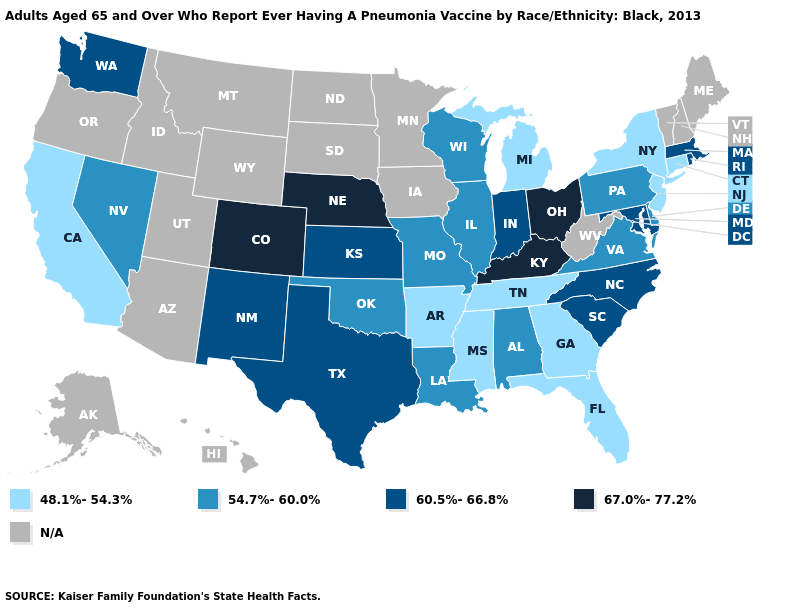Does Wisconsin have the lowest value in the USA?
Write a very short answer. No. Does Kentucky have the highest value in the USA?
Concise answer only. Yes. What is the value of California?
Give a very brief answer. 48.1%-54.3%. What is the highest value in states that border Massachusetts?
Short answer required. 60.5%-66.8%. Does Colorado have the highest value in the West?
Keep it brief. Yes. Is the legend a continuous bar?
Be succinct. No. What is the value of Arkansas?
Write a very short answer. 48.1%-54.3%. What is the value of South Dakota?
Answer briefly. N/A. What is the lowest value in the MidWest?
Short answer required. 48.1%-54.3%. What is the value of Arkansas?
Quick response, please. 48.1%-54.3%. What is the value of Maine?
Write a very short answer. N/A. What is the value of Missouri?
Write a very short answer. 54.7%-60.0%. Name the states that have a value in the range 54.7%-60.0%?
Short answer required. Alabama, Delaware, Illinois, Louisiana, Missouri, Nevada, Oklahoma, Pennsylvania, Virginia, Wisconsin. Does Wisconsin have the lowest value in the MidWest?
Answer briefly. No. Does Michigan have the lowest value in the USA?
Answer briefly. Yes. 